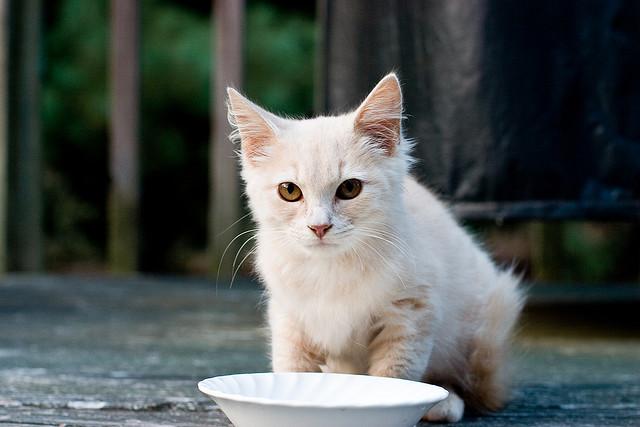Which animal is this?
Give a very brief answer. Cat. Does the cat have two different colored eyes?
Write a very short answer. No. What animal is this?
Concise answer only. Cat. 